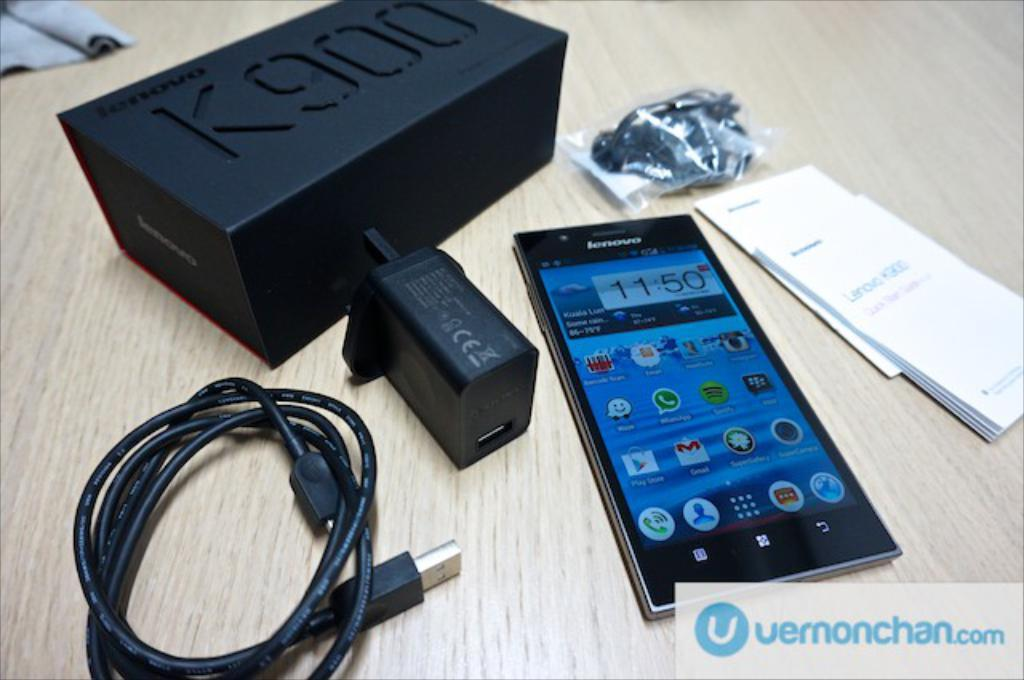<image>
Create a compact narrative representing the image presented. A black lenovo phone next to a black box with K900 written on it. 